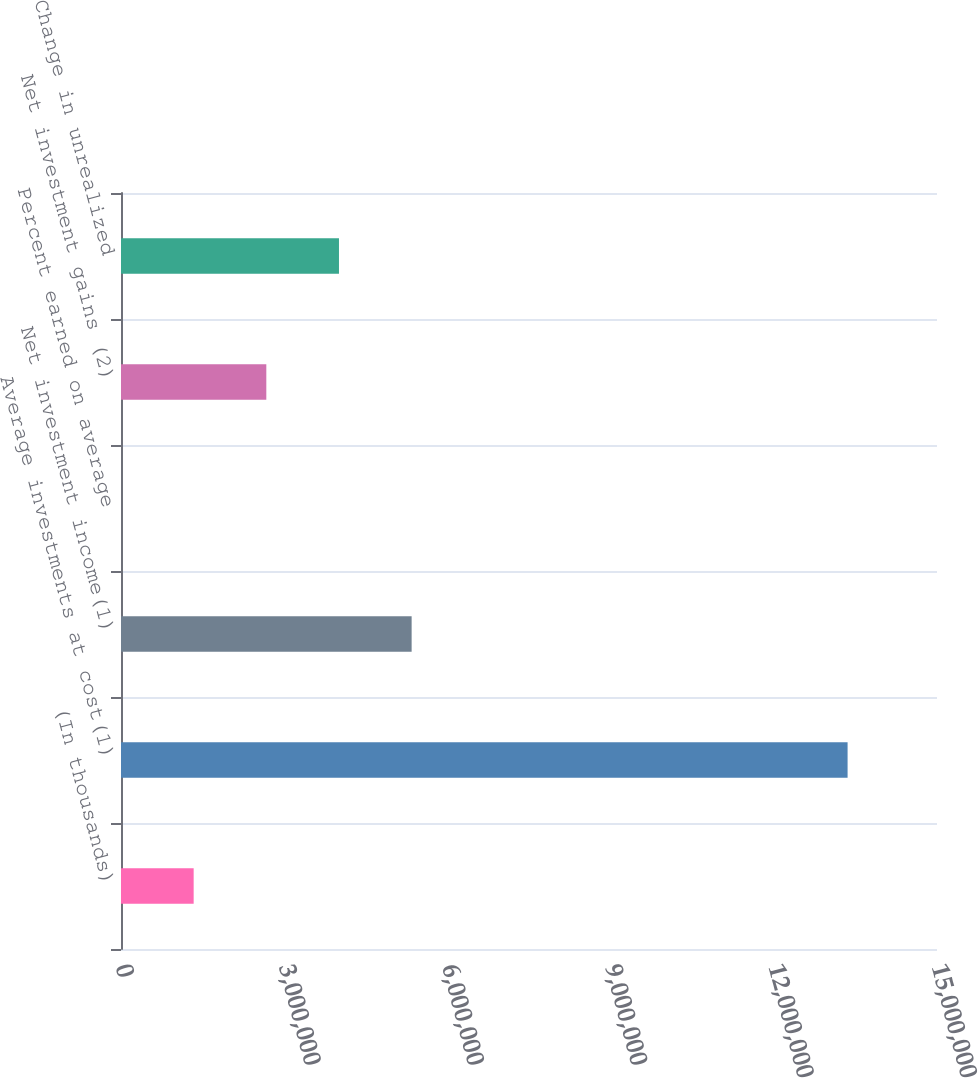<chart> <loc_0><loc_0><loc_500><loc_500><bar_chart><fcel>(In thousands)<fcel>Average investments at cost(1)<fcel>Net investment income(1)<fcel>Percent earned on average<fcel>Net investment gains (2)<fcel>Change in unrealized<nl><fcel>1.33564e+06<fcel>1.33564e+07<fcel>5.34255e+06<fcel>4<fcel>2.67128e+06<fcel>4.00692e+06<nl></chart> 